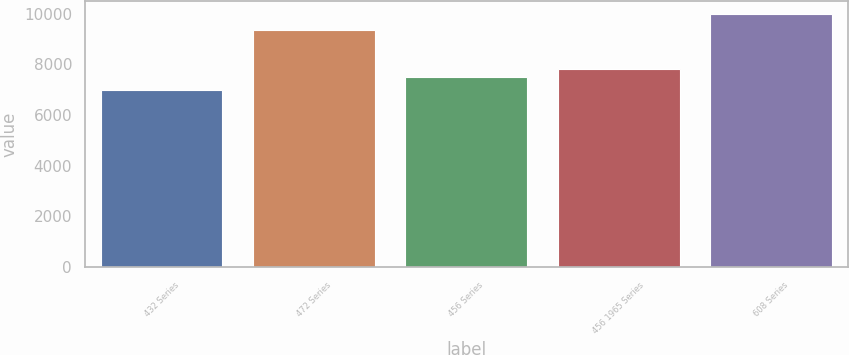<chart> <loc_0><loc_0><loc_500><loc_500><bar_chart><fcel>432 Series<fcel>472 Series<fcel>456 Series<fcel>456 1965 Series<fcel>608 Series<nl><fcel>7000<fcel>9350<fcel>7500<fcel>7800<fcel>10000<nl></chart> 